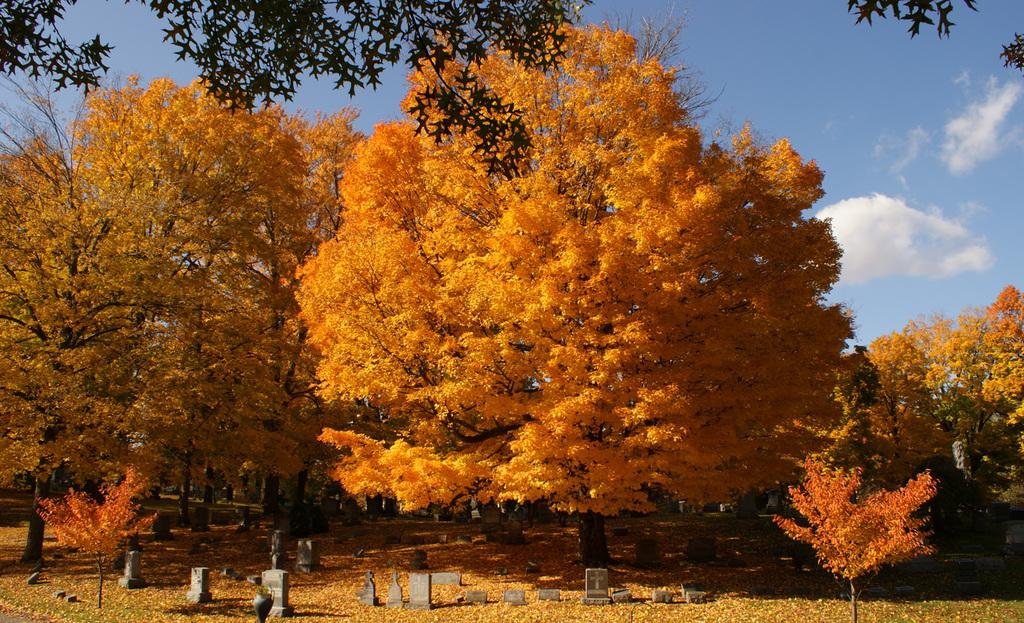What type of trees are visible in the image? The image contains autumn trees. What other elements can be seen at the bottom of the picture? There are gravestones at the bottom of the picture. What is visible in the sky in the image? There are clouds in the sky. What is the chance of spotting a spy among the autumn trees in the image? There is no mention of a spy in the image, so it is not possible to determine the chance of spotting one. 